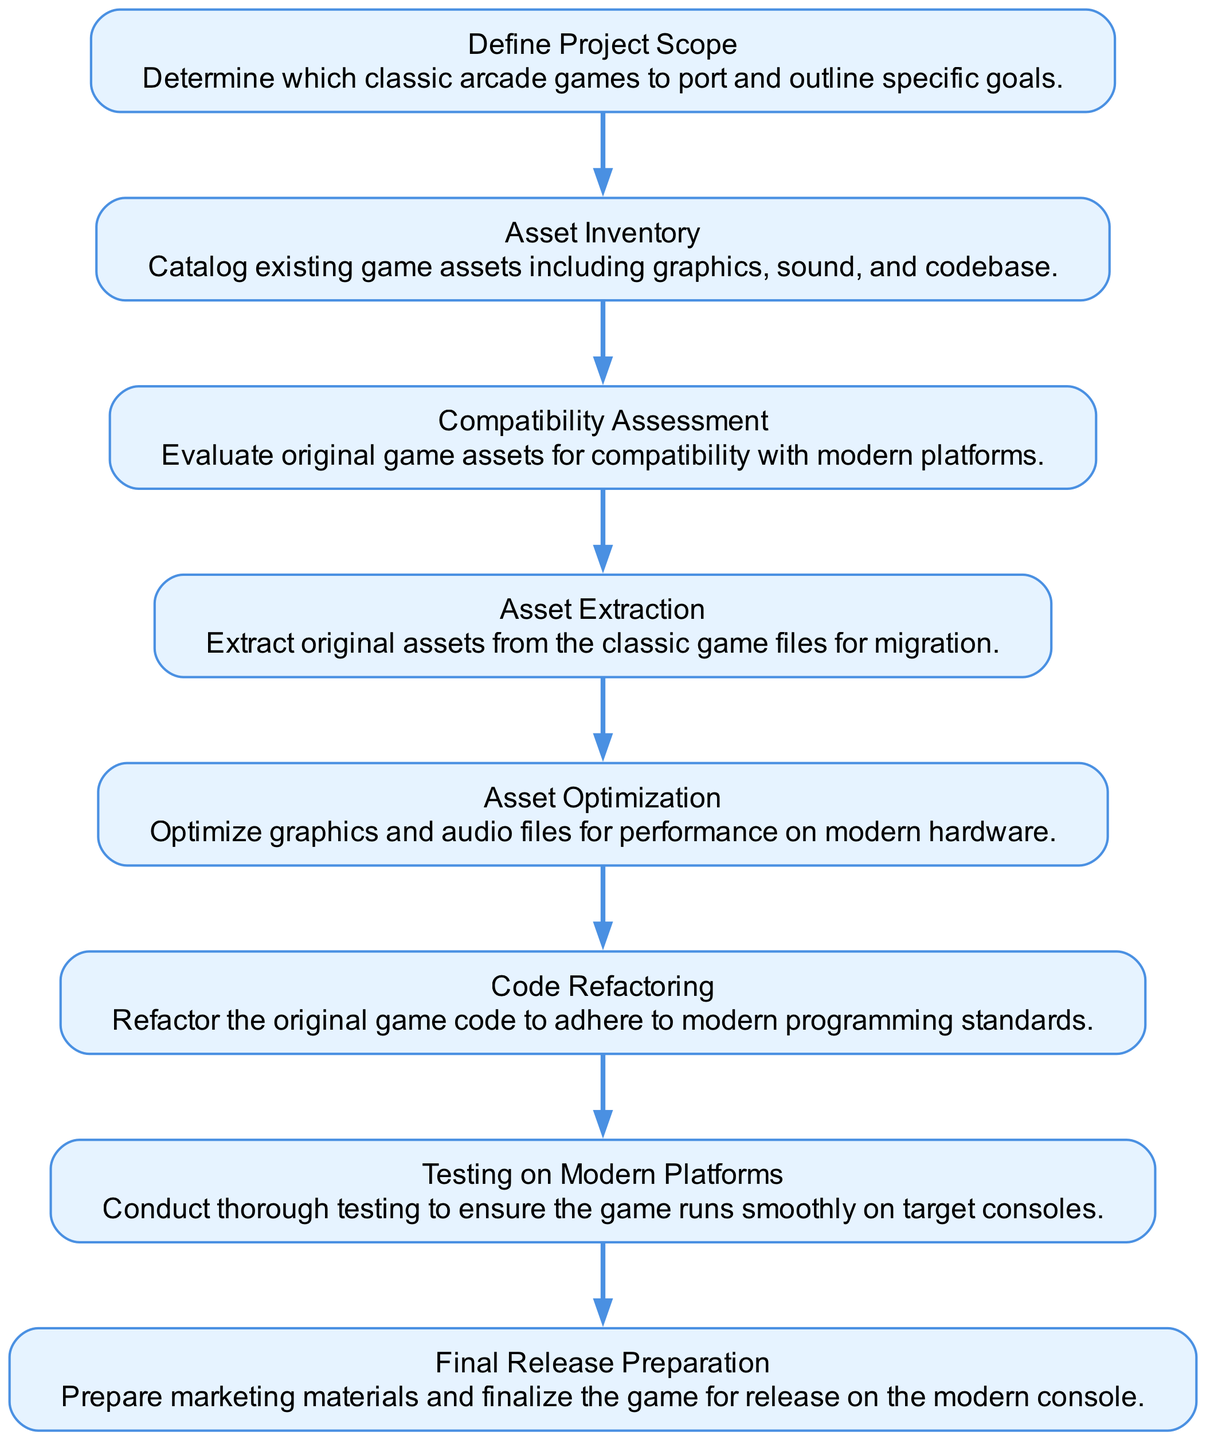What is the first step in the asset migration strategy? The first step in the flow chart is "Define Project Scope", which outlines the goals for which classic arcade games to port.
Answer: Define Project Scope How many nodes are present in the diagram? Counting the elements listed, there are a total of 8 nodes in the diagram corresponding to each step in the asset migration strategy.
Answer: 8 What is the last step mentioned in the flow chart? The last step highlighted in the diagram is "Final Release Preparation", which involves preparing marketing materials for the game release.
Answer: Final Release Preparation What step comes after "Asset Optimization"? After "Asset Optimization", the next step in the sequence is "Code Refactoring", which involves updating the original game code to meet modern standards.
Answer: Code Refactoring Which step assesses compatibility with modern platforms? "Compatibility Assessment" is the step that evaluates original game assets for their compatibility with modern platforms.
Answer: Compatibility Assessment What is the relationship between "Asset Inventory" and "Asset Extraction"? "Asset Inventory" is the step that comes before "Asset Extraction", indicating that a complete catalog of the existing game assets must be done before extracting them.
Answer: Asset Inventory precedes Asset Extraction Which step is focused on testing the game? The step focused on testing the game is "Testing on Modern Platforms", where thorough testing is conducted to ensure the game performs well on target consoles.
Answer: Testing on Modern Platforms How many edges connect the nodes in the diagram? Each of the 8 nodes is connected in a linear progression, forming 7 edges that connect the nodes from start to finish.
Answer: 7 What step follows after "Code Refactoring"? The step that follows "Code Refactoring" is "Testing on Modern Platforms", where testing occurs to ensure the game operates smoothly.
Answer: Testing on Modern Platforms 